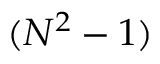<formula> <loc_0><loc_0><loc_500><loc_500>( N ^ { 2 } - 1 )</formula> 